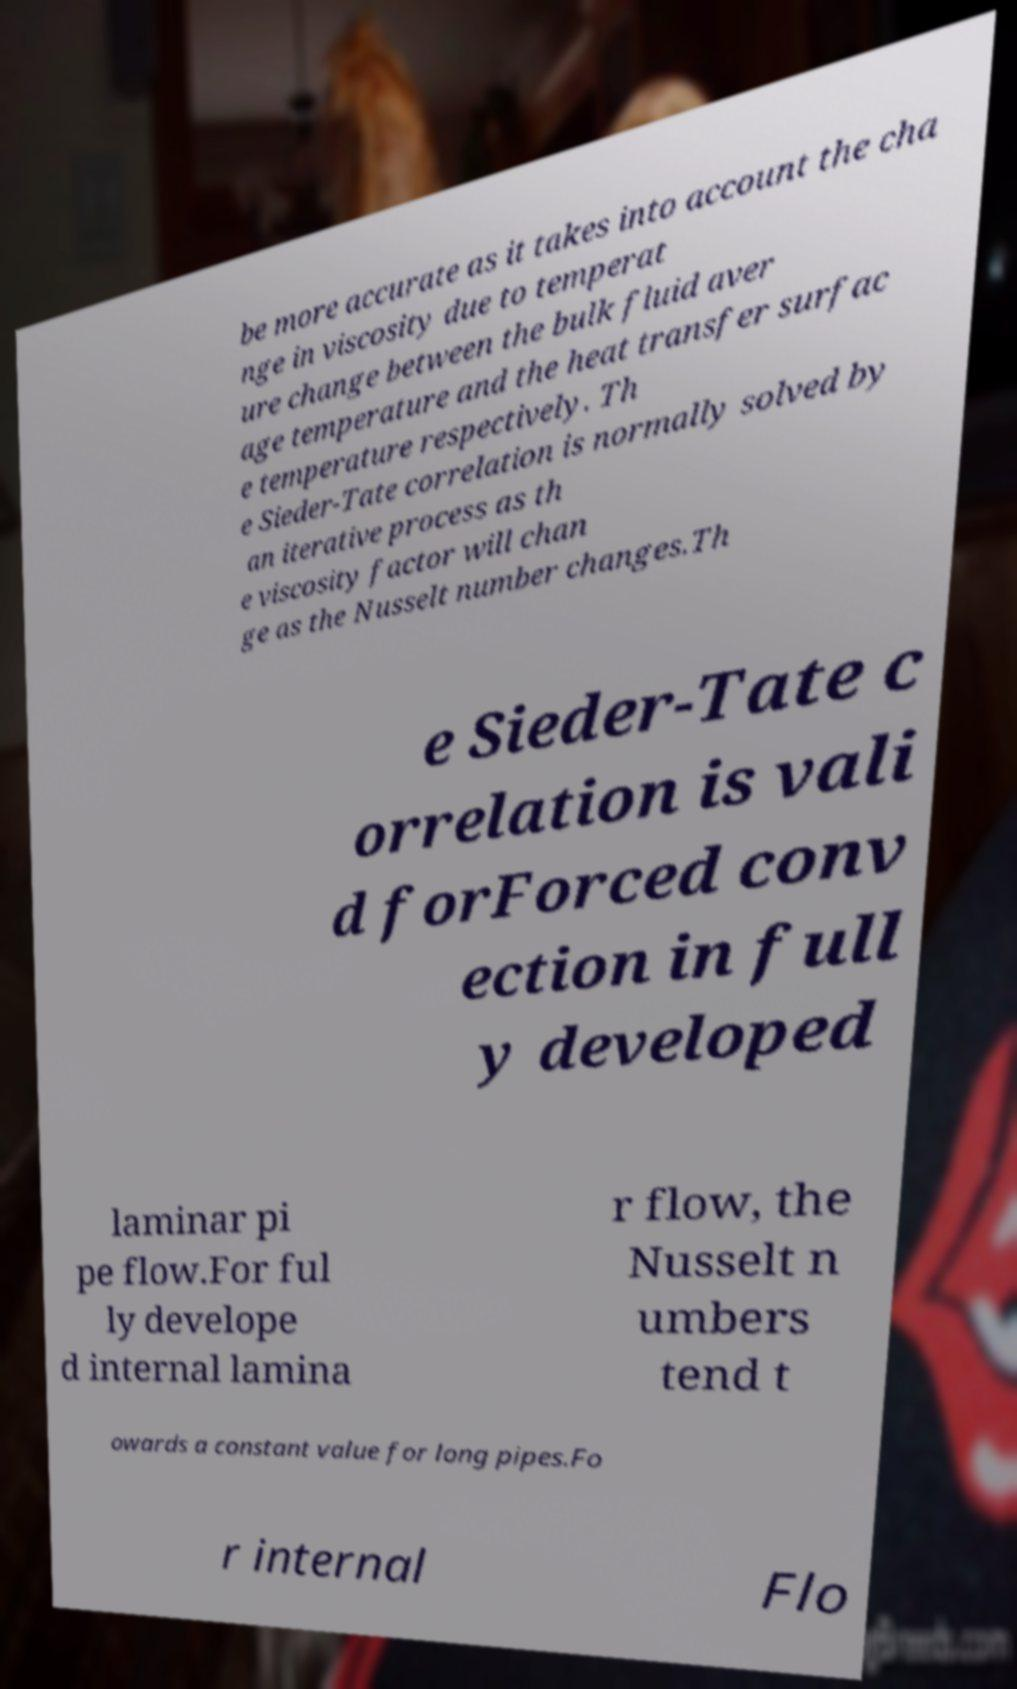I need the written content from this picture converted into text. Can you do that? be more accurate as it takes into account the cha nge in viscosity due to temperat ure change between the bulk fluid aver age temperature and the heat transfer surfac e temperature respectively. Th e Sieder-Tate correlation is normally solved by an iterative process as th e viscosity factor will chan ge as the Nusselt number changes.Th e Sieder-Tate c orrelation is vali d forForced conv ection in full y developed laminar pi pe flow.For ful ly develope d internal lamina r flow, the Nusselt n umbers tend t owards a constant value for long pipes.Fo r internal Flo 